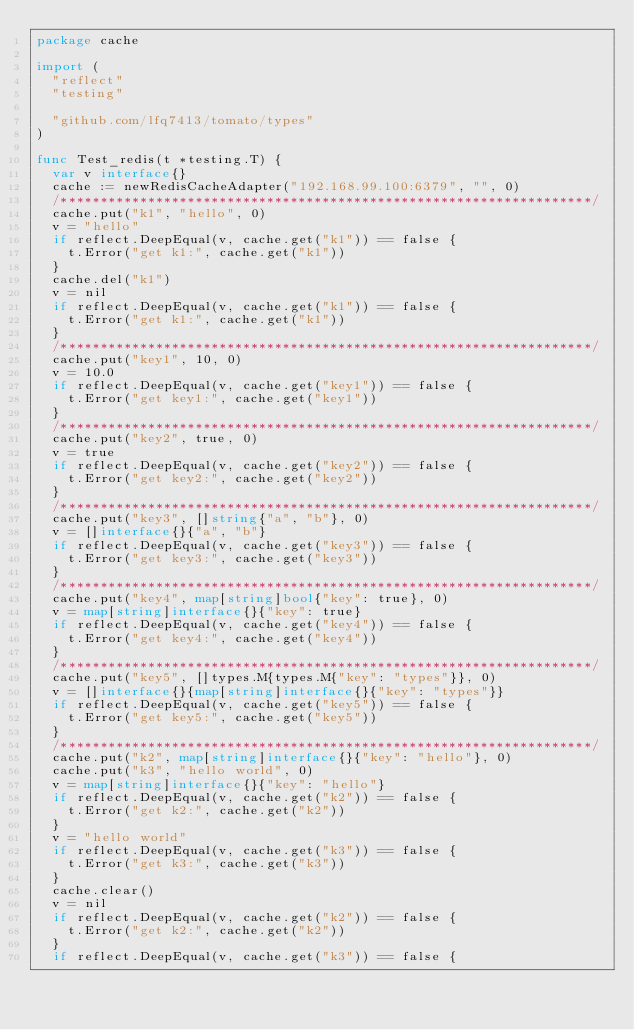<code> <loc_0><loc_0><loc_500><loc_500><_Go_>package cache

import (
	"reflect"
	"testing"

	"github.com/lfq7413/tomato/types"
)

func Test_redis(t *testing.T) {
	var v interface{}
	cache := newRedisCacheAdapter("192.168.99.100:6379", "", 0)
	/*******************************************************************/
	cache.put("k1", "hello", 0)
	v = "hello"
	if reflect.DeepEqual(v, cache.get("k1")) == false {
		t.Error("get k1:", cache.get("k1"))
	}
	cache.del("k1")
	v = nil
	if reflect.DeepEqual(v, cache.get("k1")) == false {
		t.Error("get k1:", cache.get("k1"))
	}
	/*******************************************************************/
	cache.put("key1", 10, 0)
	v = 10.0
	if reflect.DeepEqual(v, cache.get("key1")) == false {
		t.Error("get key1:", cache.get("key1"))
	}
	/*******************************************************************/
	cache.put("key2", true, 0)
	v = true
	if reflect.DeepEqual(v, cache.get("key2")) == false {
		t.Error("get key2:", cache.get("key2"))
	}
	/*******************************************************************/
	cache.put("key3", []string{"a", "b"}, 0)
	v = []interface{}{"a", "b"}
	if reflect.DeepEqual(v, cache.get("key3")) == false {
		t.Error("get key3:", cache.get("key3"))
	}
	/*******************************************************************/
	cache.put("key4", map[string]bool{"key": true}, 0)
	v = map[string]interface{}{"key": true}
	if reflect.DeepEqual(v, cache.get("key4")) == false {
		t.Error("get key4:", cache.get("key4"))
	}
	/*******************************************************************/
	cache.put("key5", []types.M{types.M{"key": "types"}}, 0)
	v = []interface{}{map[string]interface{}{"key": "types"}}
	if reflect.DeepEqual(v, cache.get("key5")) == false {
		t.Error("get key5:", cache.get("key5"))
	}
	/*******************************************************************/
	cache.put("k2", map[string]interface{}{"key": "hello"}, 0)
	cache.put("k3", "hello world", 0)
	v = map[string]interface{}{"key": "hello"}
	if reflect.DeepEqual(v, cache.get("k2")) == false {
		t.Error("get k2:", cache.get("k2"))
	}
	v = "hello world"
	if reflect.DeepEqual(v, cache.get("k3")) == false {
		t.Error("get k3:", cache.get("k3"))
	}
	cache.clear()
	v = nil
	if reflect.DeepEqual(v, cache.get("k2")) == false {
		t.Error("get k2:", cache.get("k2"))
	}
	if reflect.DeepEqual(v, cache.get("k3")) == false {</code> 